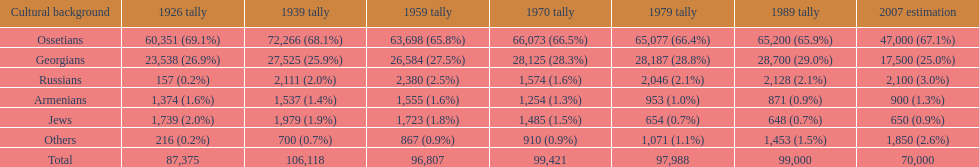What was the first census that saw a russian population of over 2,000? 1939 census. 